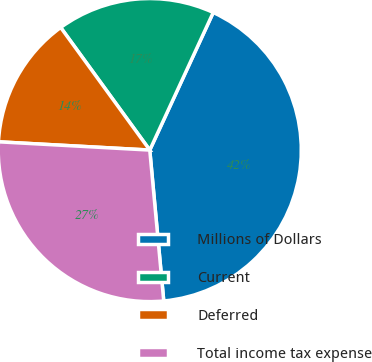Convert chart. <chart><loc_0><loc_0><loc_500><loc_500><pie_chart><fcel>Millions of Dollars<fcel>Current<fcel>Deferred<fcel>Total income tax expense<nl><fcel>41.65%<fcel>16.88%<fcel>14.13%<fcel>27.34%<nl></chart> 